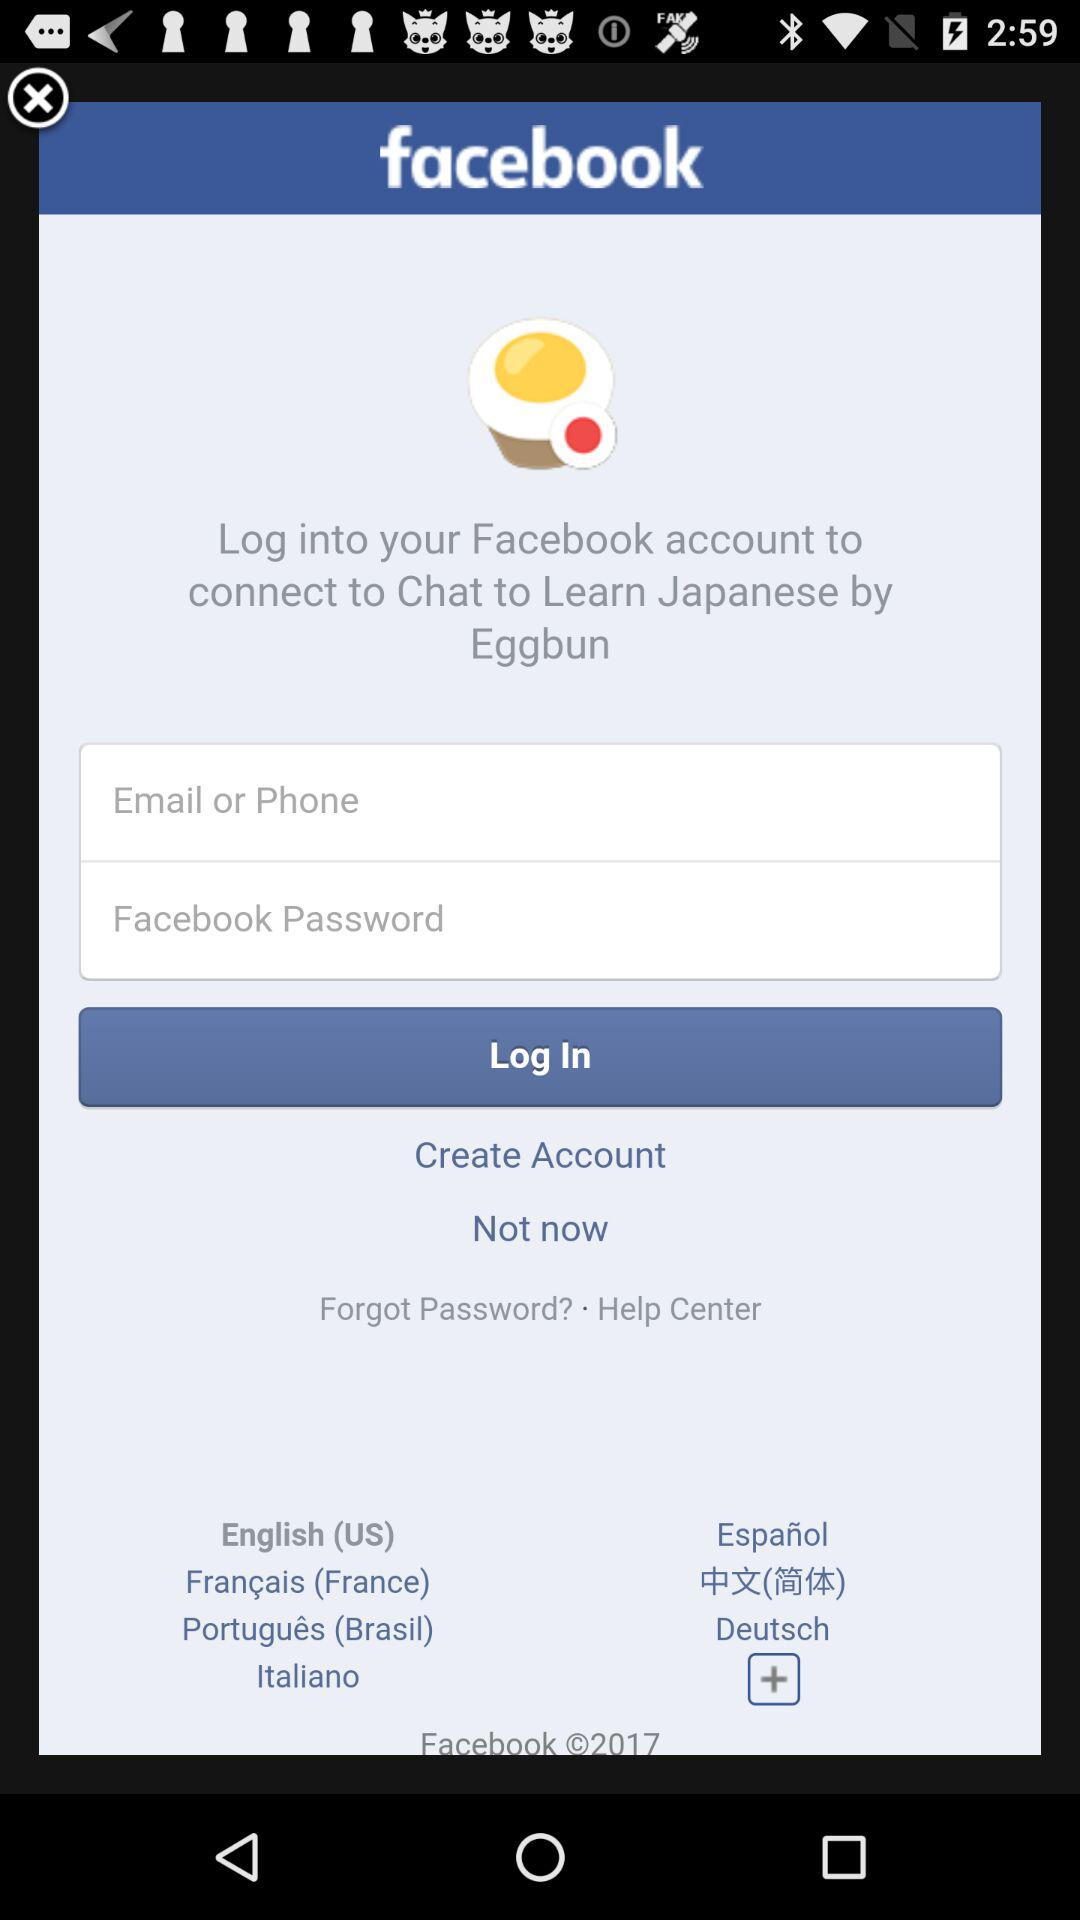Through what application can we log in? We can log in through "Facebook". 